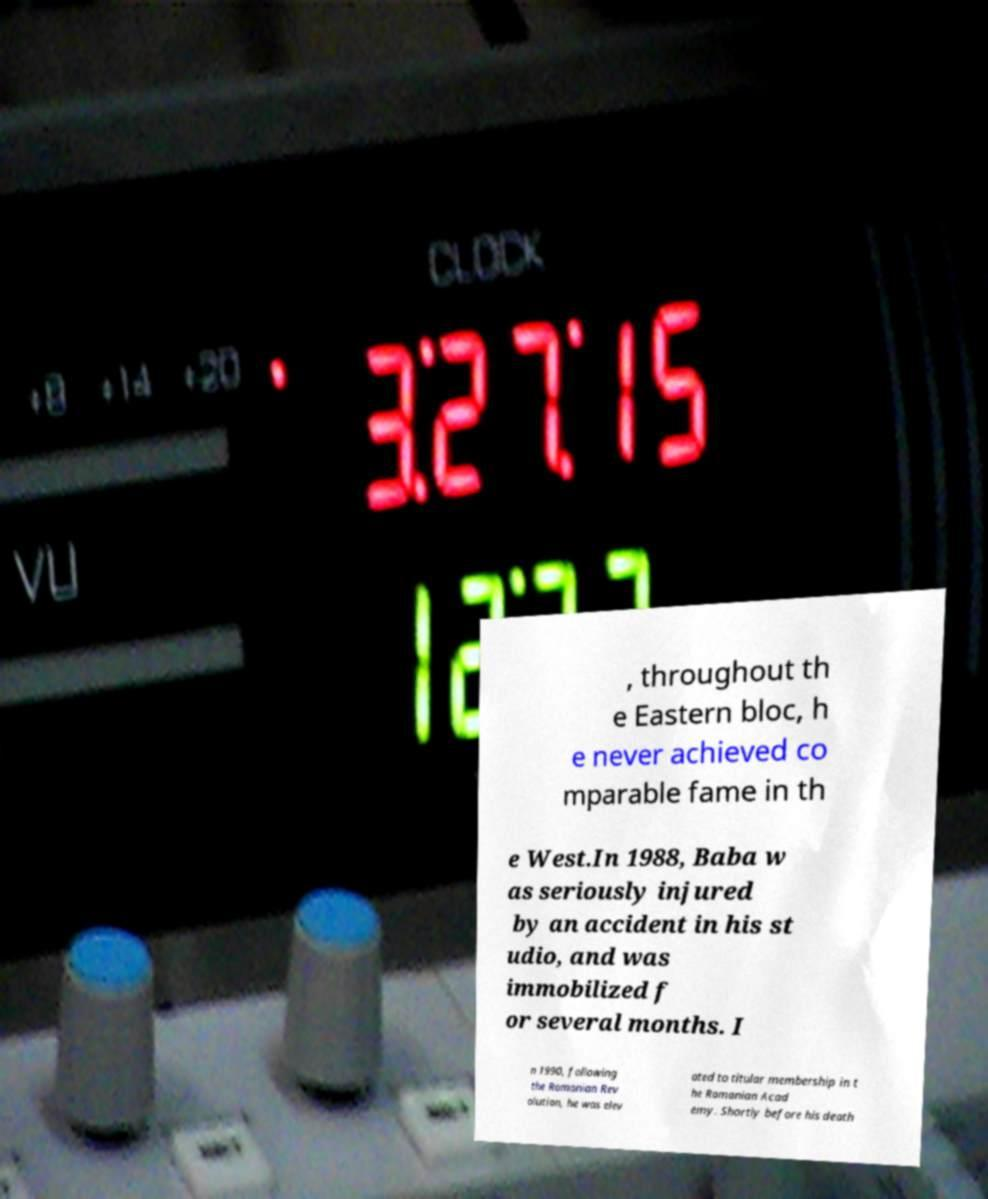Could you assist in decoding the text presented in this image and type it out clearly? , throughout th e Eastern bloc, h e never achieved co mparable fame in th e West.In 1988, Baba w as seriously injured by an accident in his st udio, and was immobilized f or several months. I n 1990, following the Romanian Rev olution, he was elev ated to titular membership in t he Romanian Acad emy. Shortly before his death 